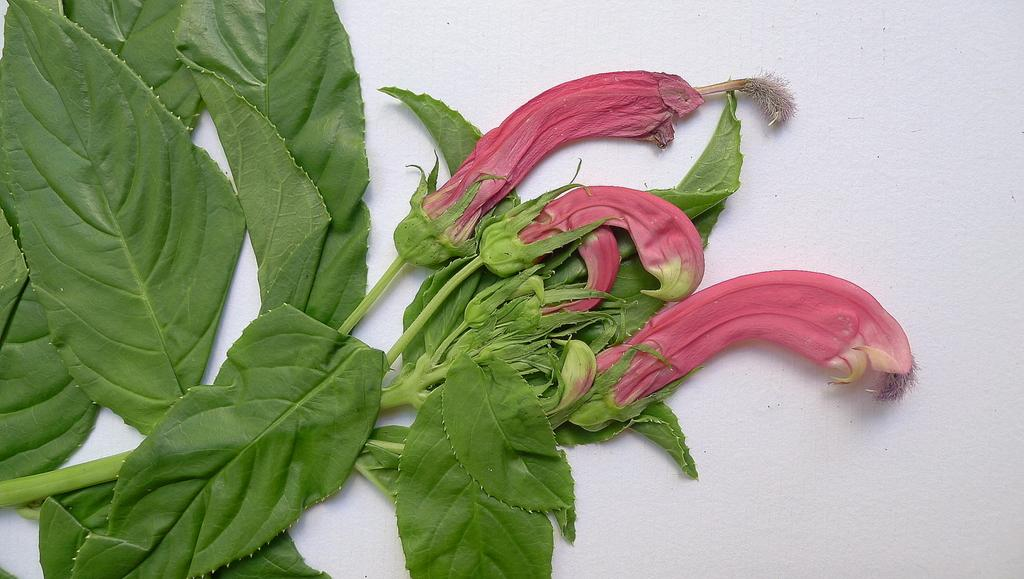What is present in the image? There is a plant in the image. What can be observed about the plant? The plant has flowers. What is the color of the surface the plant is on? The plant is on a white surface. What type of tramp can be seen in the image? There is no tramp present in the image; it features a plant with flowers on a white surface. How does the crow interact with the plant in the image? There is no crow present in the image; it only features a plant with flowers on a white surface. 